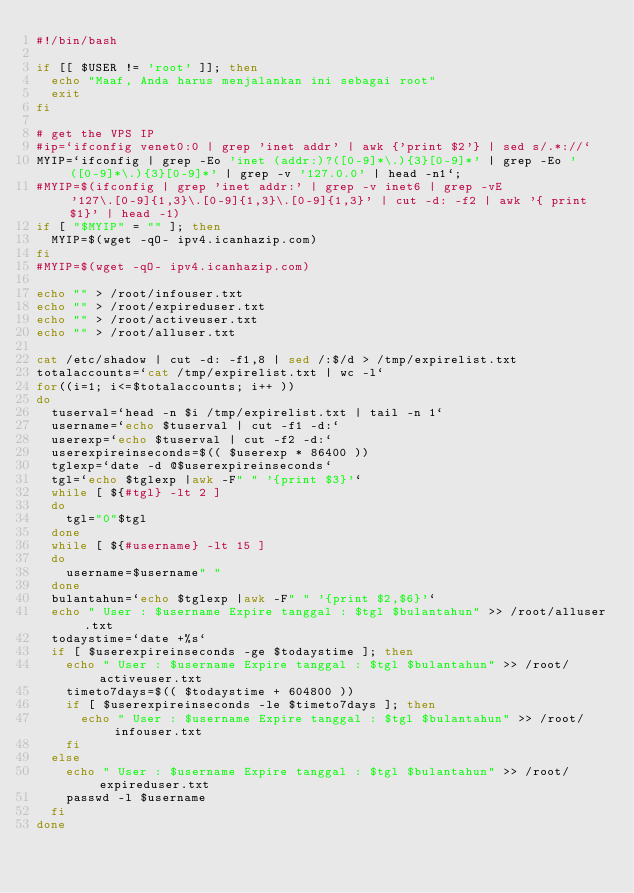Convert code to text. <code><loc_0><loc_0><loc_500><loc_500><_Bash_>#!/bin/bash

if [[ $USER != 'root' ]]; then
	echo "Maaf, Anda harus menjalankan ini sebagai root"
	exit
fi

# get the VPS IP
#ip=`ifconfig venet0:0 | grep 'inet addr' | awk {'print $2'} | sed s/.*://`
MYIP=`ifconfig | grep -Eo 'inet (addr:)?([0-9]*\.){3}[0-9]*' | grep -Eo '([0-9]*\.){3}[0-9]*' | grep -v '127.0.0' | head -n1`;
#MYIP=$(ifconfig | grep 'inet addr:' | grep -v inet6 | grep -vE '127\.[0-9]{1,3}\.[0-9]{1,3}\.[0-9]{1,3}' | cut -d: -f2 | awk '{ print $1}' | head -1)
if [ "$MYIP" = "" ]; then
	MYIP=$(wget -qO- ipv4.icanhazip.com)
fi
#MYIP=$(wget -qO- ipv4.icanhazip.com)

echo "" > /root/infouser.txt
echo "" > /root/expireduser.txt
echo "" > /root/activeuser.txt
echo "" > /root/alluser.txt

cat /etc/shadow | cut -d: -f1,8 | sed /:$/d > /tmp/expirelist.txt
totalaccounts=`cat /tmp/expirelist.txt | wc -l`
for((i=1; i<=$totalaccounts; i++ ))
do
	tuserval=`head -n $i /tmp/expirelist.txt | tail -n 1`
	username=`echo $tuserval | cut -f1 -d:`
	userexp=`echo $tuserval | cut -f2 -d:`
	userexpireinseconds=$(( $userexp * 86400 ))
	tglexp=`date -d @$userexpireinseconds`
	tgl=`echo $tglexp |awk -F" " '{print $3}'`
	while [ ${#tgl} -lt 2 ]
	do
		tgl="0"$tgl
	done
	while [ ${#username} -lt 15 ]
	do
		username=$username" "
	done
	bulantahun=`echo $tglexp |awk -F" " '{print $2,$6}'`
	echo " User : $username Expire tanggal : $tgl $bulantahun" >> /root/alluser.txt
	todaystime=`date +%s`
	if [ $userexpireinseconds -ge $todaystime ]; then
		echo " User : $username Expire tanggal : $tgl $bulantahun" >> /root/activeuser.txt
		timeto7days=$(( $todaystime + 604800 ))
		if [ $userexpireinseconds -le $timeto7days ]; then
			echo " User : $username Expire tanggal : $tgl $bulantahun" >> /root/infouser.txt
		fi
	else
		echo " User : $username Expire tanggal : $tgl $bulantahun" >> /root/expireduser.txt
		passwd -l $username
	fi
done

</code> 